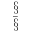<formula> <loc_0><loc_0><loc_500><loc_500>\begin{array} { c } { \S } \\ { { \bar { \S } } } \end{array}</formula> 